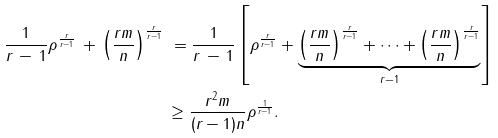<formula> <loc_0><loc_0><loc_500><loc_500>\frac { 1 } { r \, - \, 1 } \rho ^ { \frac { r } { r - 1 } } \, + \, \left ( \frac { r m } { n } \right ) ^ { \frac { r } { r - 1 } } \, & \, = \frac { 1 } { r \, - \, 1 } \left [ \rho ^ { \frac { r } { r - 1 } } + \underbrace { \left ( \frac { r m } { n } \right ) ^ { \frac { r } { r - 1 } } + \cdots + \left ( \frac { r m } { n } \right ) ^ { \frac { r } { r - 1 } } } _ { r - 1 } \right ] \\ & \geq \frac { r ^ { 2 } m } { ( r - 1 ) n } \rho ^ { \frac { 1 } { r - 1 } } .</formula> 